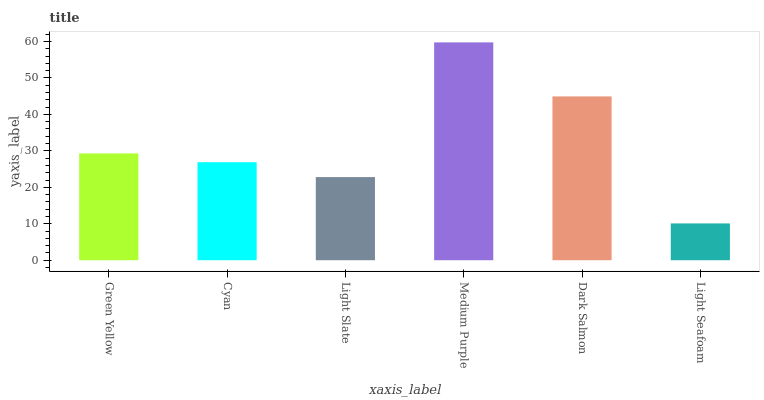Is Light Seafoam the minimum?
Answer yes or no. Yes. Is Medium Purple the maximum?
Answer yes or no. Yes. Is Cyan the minimum?
Answer yes or no. No. Is Cyan the maximum?
Answer yes or no. No. Is Green Yellow greater than Cyan?
Answer yes or no. Yes. Is Cyan less than Green Yellow?
Answer yes or no. Yes. Is Cyan greater than Green Yellow?
Answer yes or no. No. Is Green Yellow less than Cyan?
Answer yes or no. No. Is Green Yellow the high median?
Answer yes or no. Yes. Is Cyan the low median?
Answer yes or no. Yes. Is Medium Purple the high median?
Answer yes or no. No. Is Green Yellow the low median?
Answer yes or no. No. 